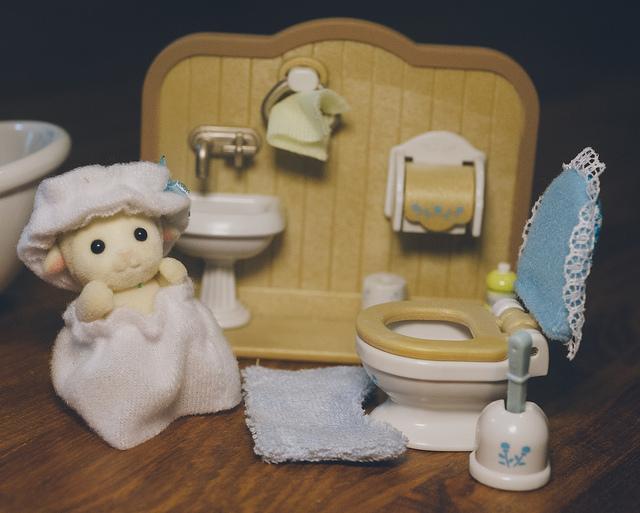How many stuffed animals are shown?
Give a very brief answer. 1. How many sinks can you see?
Give a very brief answer. 2. 